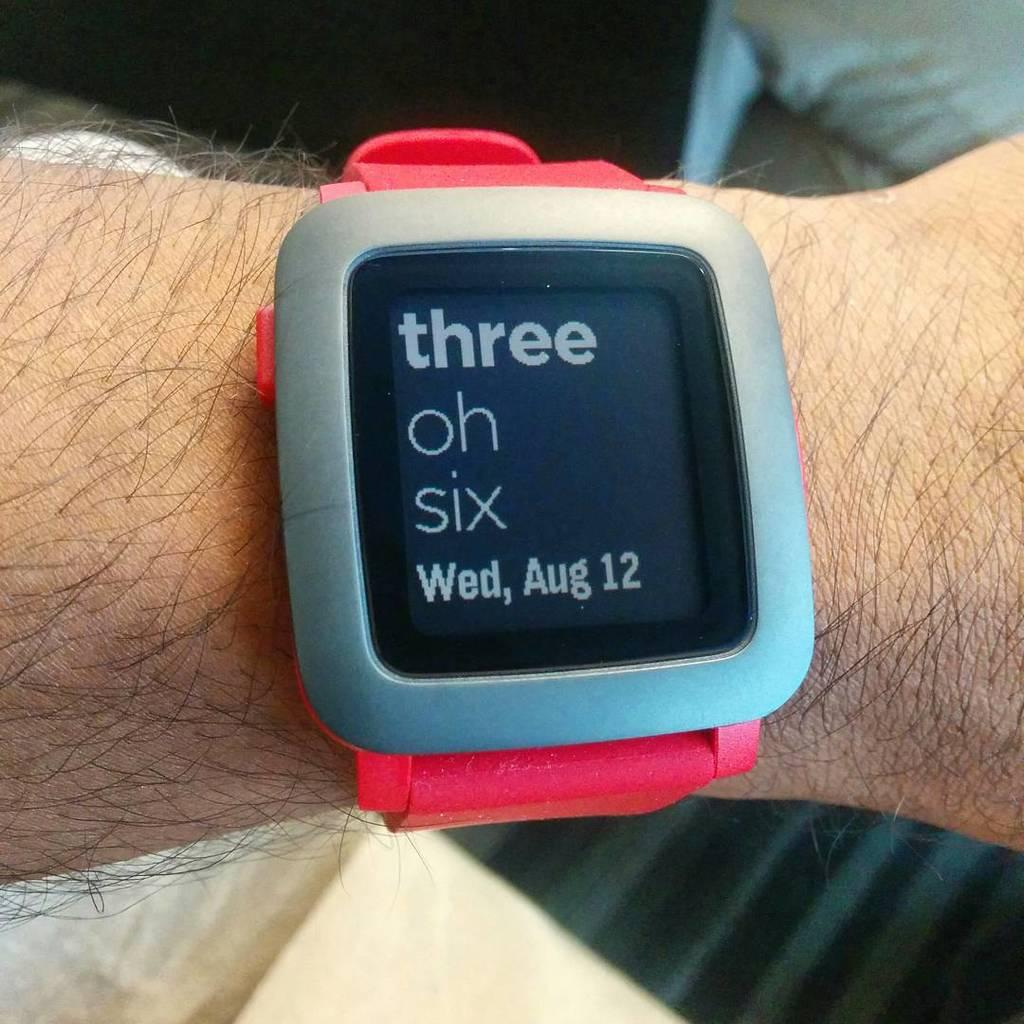Provide a one-sentence caption for the provided image. The face of the watch displays the date which is "Wed, Aug 12.". 